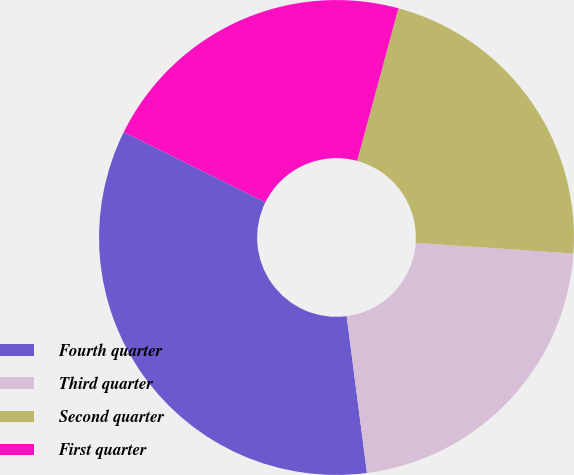Convert chart. <chart><loc_0><loc_0><loc_500><loc_500><pie_chart><fcel>Fourth quarter<fcel>Third quarter<fcel>Second quarter<fcel>First quarter<nl><fcel>34.38%<fcel>21.88%<fcel>21.88%<fcel>21.88%<nl></chart> 